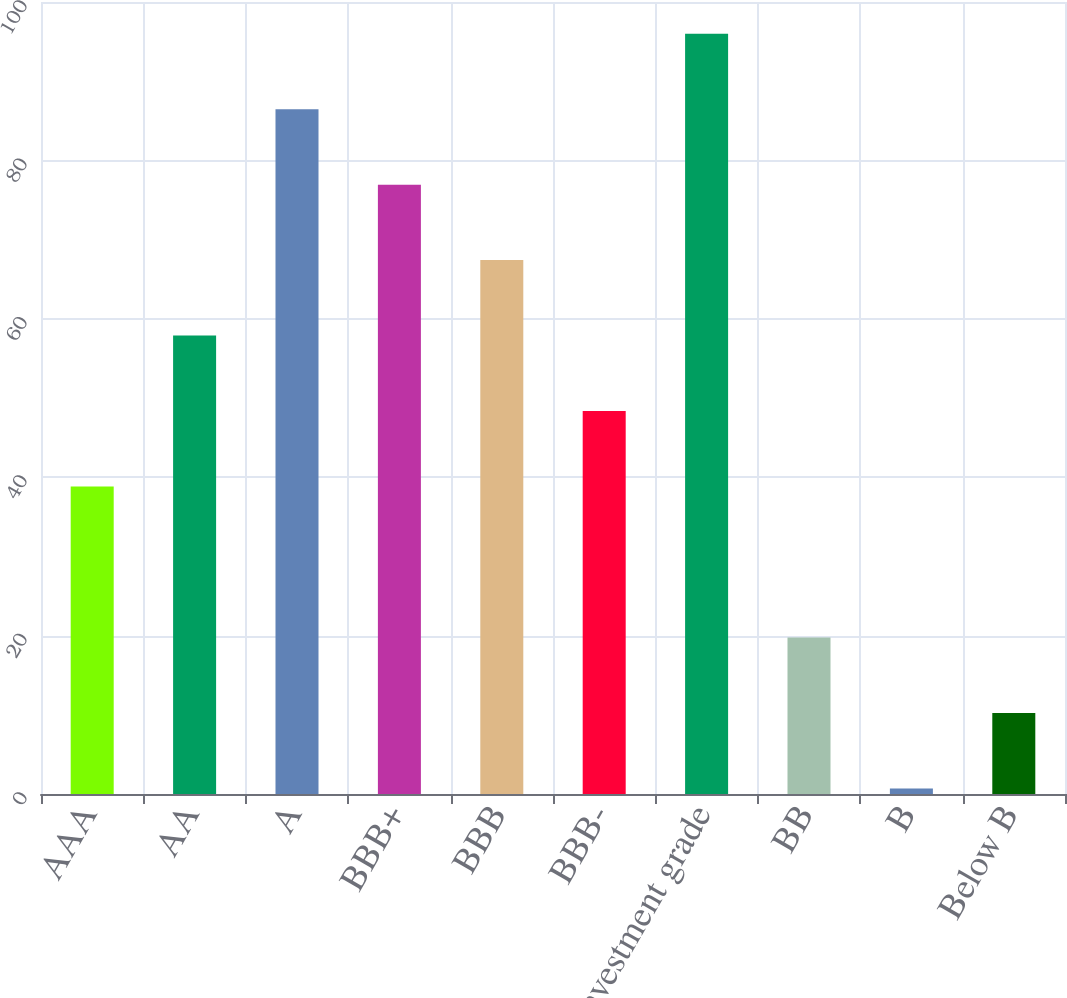Convert chart. <chart><loc_0><loc_0><loc_500><loc_500><bar_chart><fcel>AAA<fcel>AA<fcel>A<fcel>BBB+<fcel>BBB<fcel>BBB-<fcel>Investment grade<fcel>BB<fcel>B<fcel>Below B<nl><fcel>38.82<fcel>57.88<fcel>86.47<fcel>76.94<fcel>67.41<fcel>48.35<fcel>96<fcel>19.76<fcel>0.7<fcel>10.23<nl></chart> 